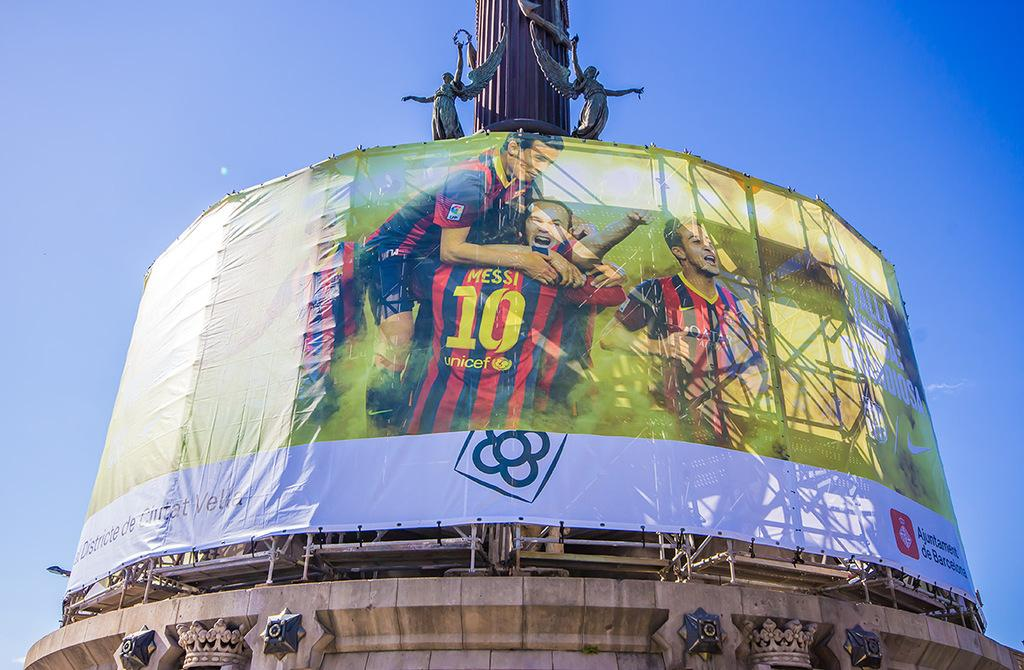What is the main subject of the image? The main subject of the image is a football players banner. What is the banner placed on? The banner is placed on a brown color tower. Are there any other objects on the tower? Yes, there are two statues on the tower. What type of tin food is depicted in the image? There is no tin food present in the image. What do the football players believe in the image? The image does not depict any football players or their beliefs. 